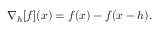<formula> <loc_0><loc_0><loc_500><loc_500>\nabla _ { h } [ f ] ( x ) = f ( x ) - f ( x - h ) .</formula> 